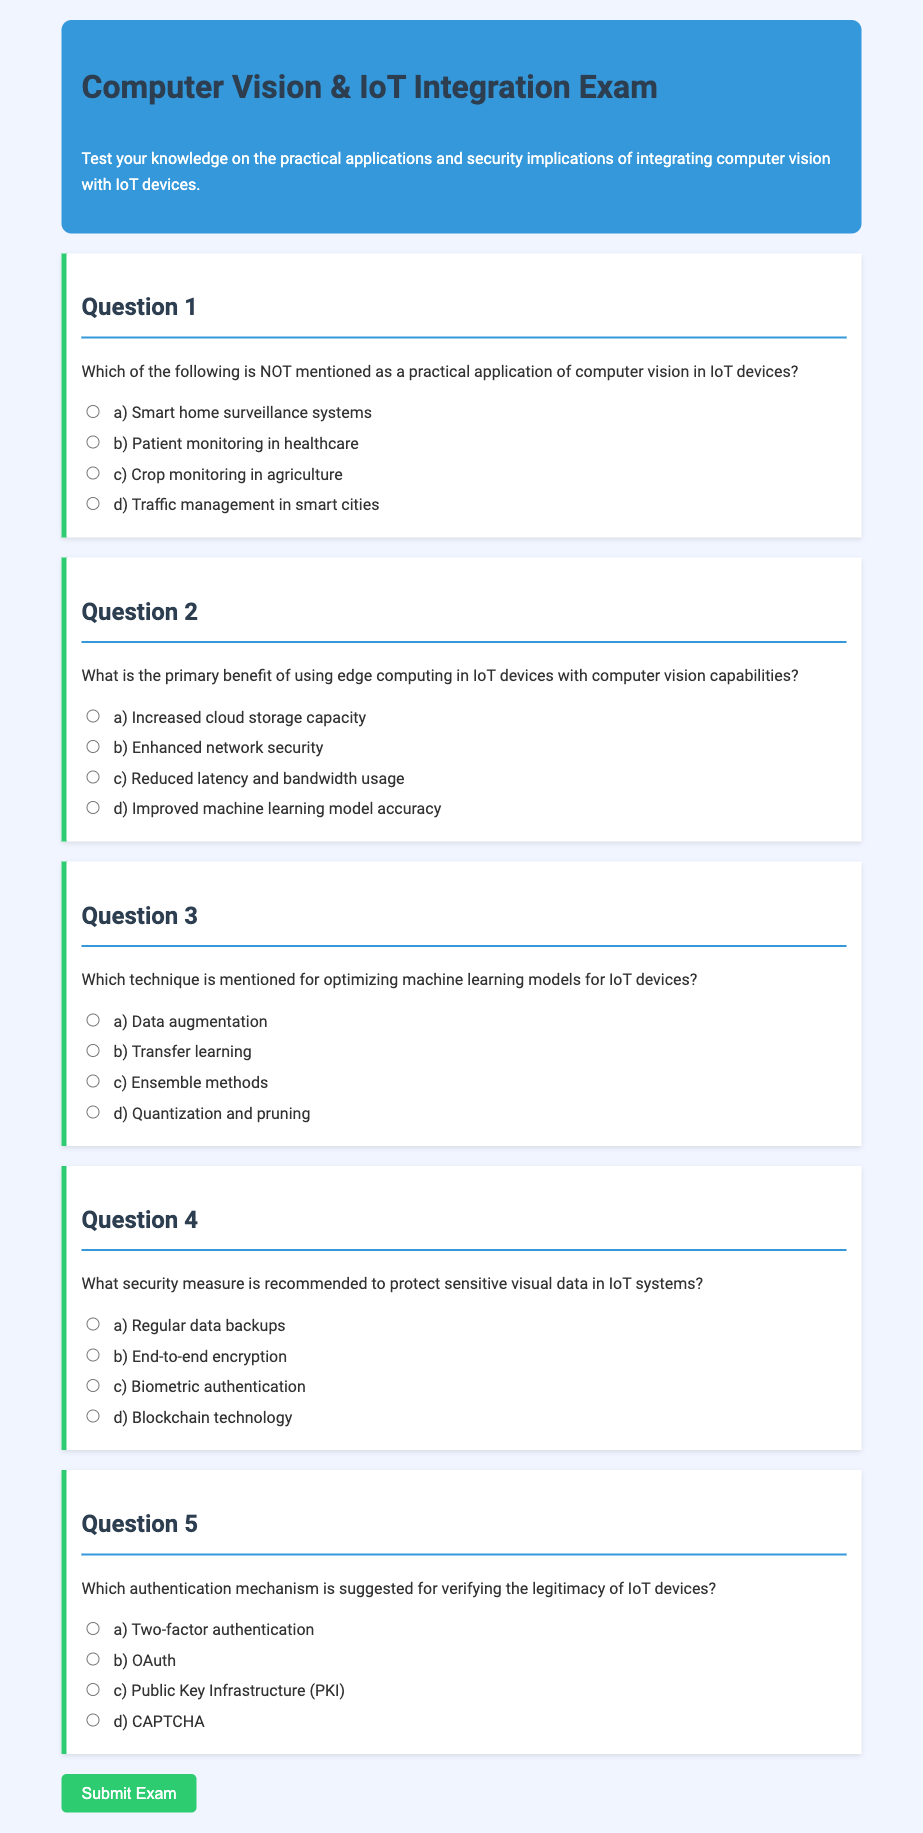Which of the following is NOT mentioned as a practical application of computer vision in IoT devices? The document lists applications such as smart home surveillance systems, patient monitoring, crop monitoring, and traffic management. One of the options does not belong to this list.
Answer: d) Traffic management in smart cities What is the primary benefit of using edge computing in IoT devices with computer vision capabilities? The document explains that edge computing primarily enhances performance through reduced latency and less bandwidth usage.
Answer: c) Reduced latency and bandwidth usage Which technique is mentioned for optimizing machine learning models for IoT devices? According to the document, various techniques for model optimization were discussed, and one is specifically named in the options presented.
Answer: d) Quantization and pruning What security measure is recommended to protect sensitive visual data in IoT systems? The document describes end-to-end encryption as a critical security measure for protecting sensitive data in IoT environments.
Answer: b) End-to-end encryption Which authentication mechanism is suggested for verifying the legitimacy of IoT devices? The document provides options for authentication mechanisms, and one specific method is highlighted as suggested for IoT device authentication.
Answer: c) Public Key Infrastructure (PKI) 